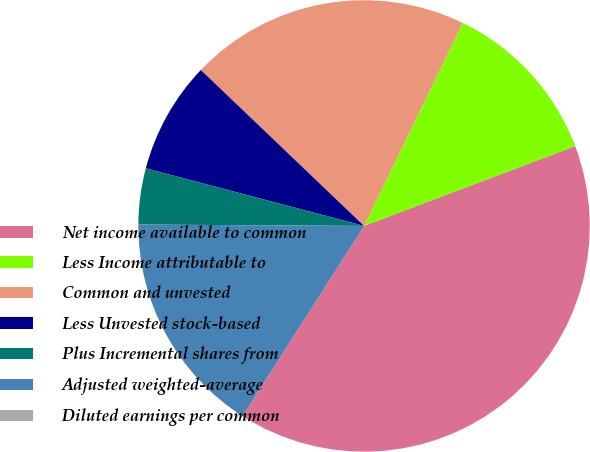Convert chart to OTSL. <chart><loc_0><loc_0><loc_500><loc_500><pie_chart><fcel>Net income available to common<fcel>Less Income attributable to<fcel>Common and unvested<fcel>Less Unvested stock-based<fcel>Plus Incremental shares from<fcel>Adjusted weighted-average<fcel>Diluted earnings per common<nl><fcel>39.8%<fcel>12.04%<fcel>20.07%<fcel>8.03%<fcel>4.01%<fcel>16.05%<fcel>0.0%<nl></chart> 